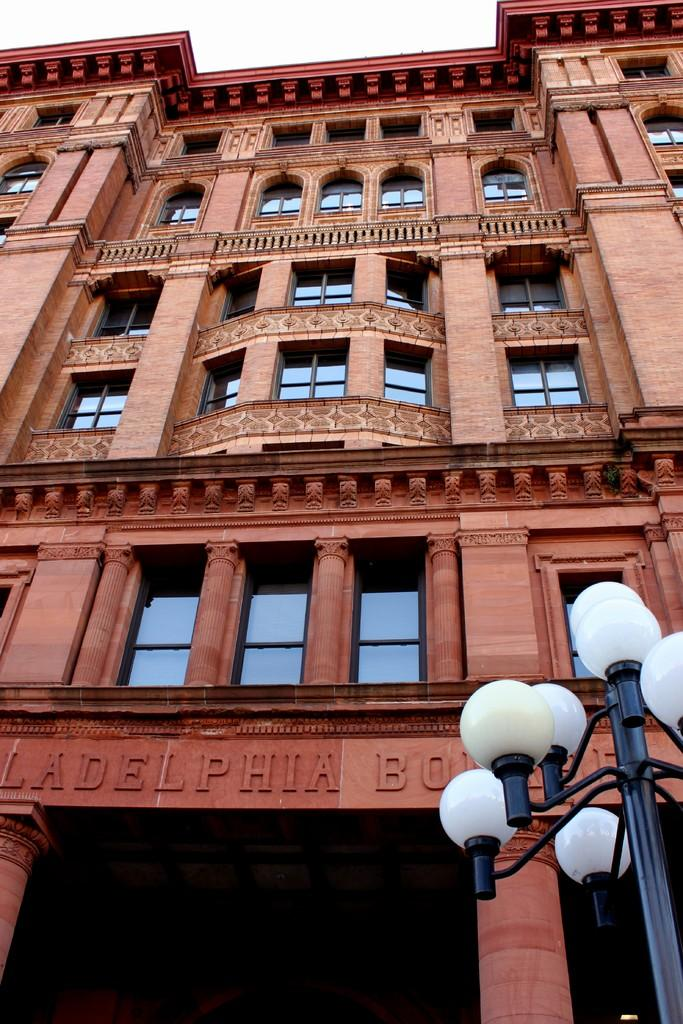What type of building is visible in the image? There is a building with glass windows in the image. What can be seen on the building? Something is written on the building. What is located on the right side of the image? There is a pole with lights on the right side of the image. What type of fruit is hanging from the border in the image? There is no fruit or border present in the image. 